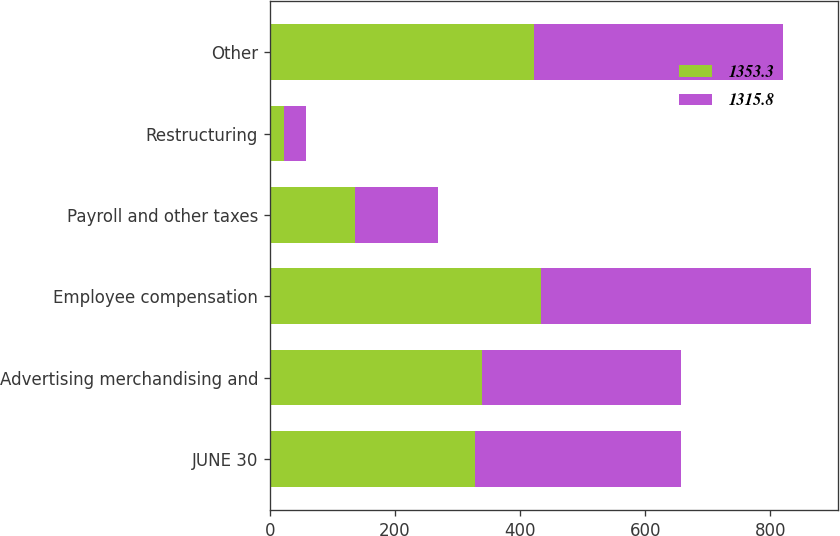<chart> <loc_0><loc_0><loc_500><loc_500><stacked_bar_chart><ecel><fcel>JUNE 30<fcel>Advertising merchandising and<fcel>Employee compensation<fcel>Payroll and other taxes<fcel>Restructuring<fcel>Other<nl><fcel>1353.3<fcel>328.5<fcel>338.4<fcel>433.3<fcel>135.7<fcel>23.2<fcel>422.7<nl><fcel>1315.8<fcel>328.5<fcel>318.6<fcel>431.4<fcel>133<fcel>34.8<fcel>398<nl></chart> 